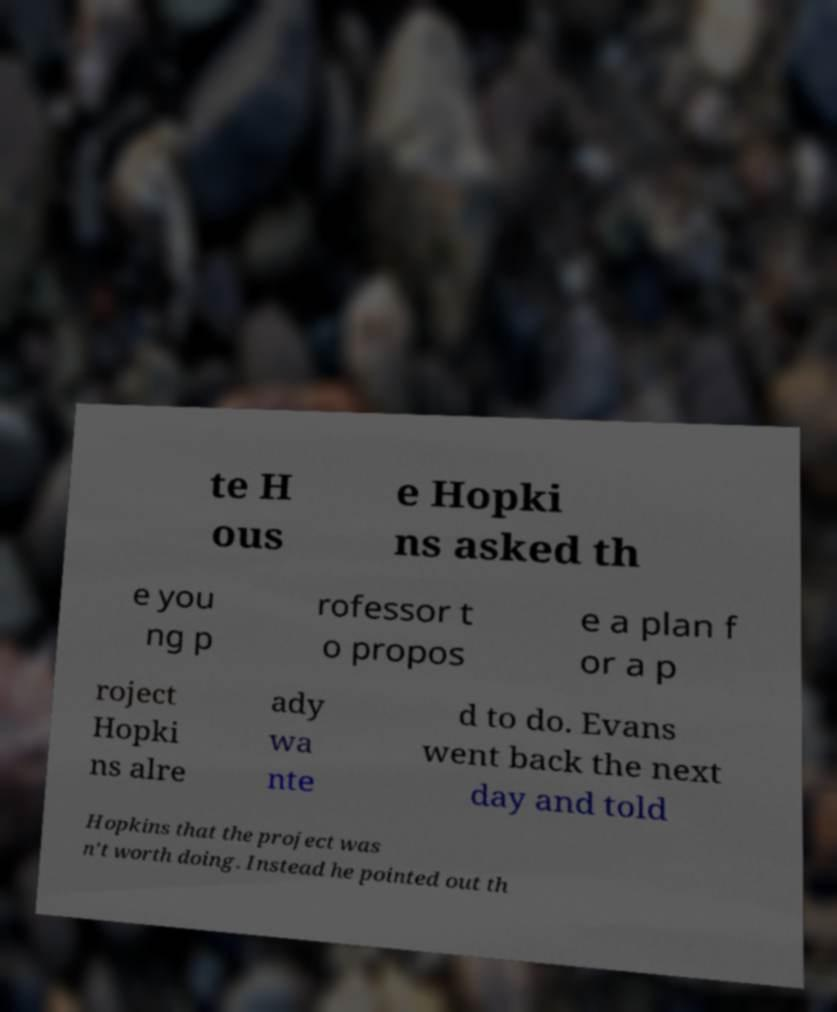There's text embedded in this image that I need extracted. Can you transcribe it verbatim? te H ous e Hopki ns asked th e you ng p rofessor t o propos e a plan f or a p roject Hopki ns alre ady wa nte d to do. Evans went back the next day and told Hopkins that the project was n't worth doing. Instead he pointed out th 